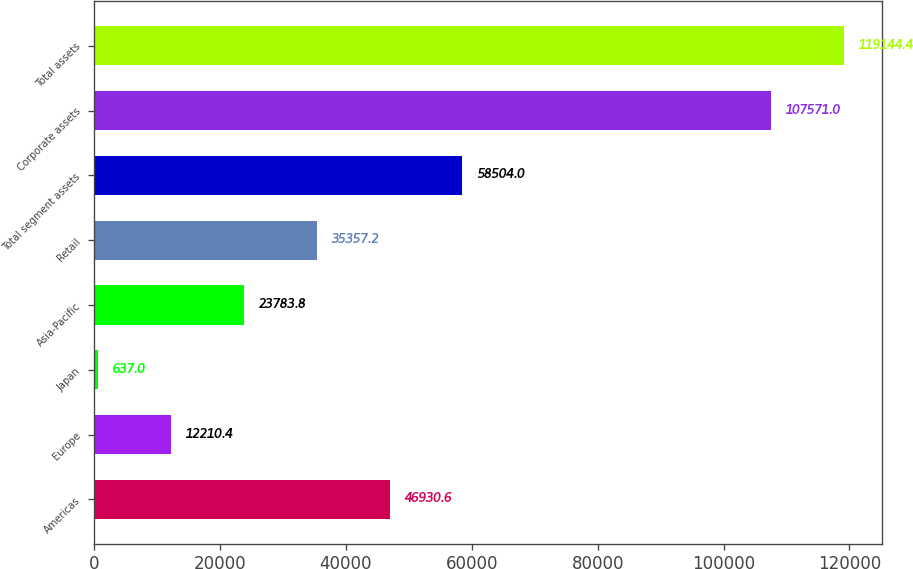Convert chart. <chart><loc_0><loc_0><loc_500><loc_500><bar_chart><fcel>Americas<fcel>Europe<fcel>Japan<fcel>Asia-Pacific<fcel>Retail<fcel>Total segment assets<fcel>Corporate assets<fcel>Total assets<nl><fcel>46930.6<fcel>12210.4<fcel>637<fcel>23783.8<fcel>35357.2<fcel>58504<fcel>107571<fcel>119144<nl></chart> 